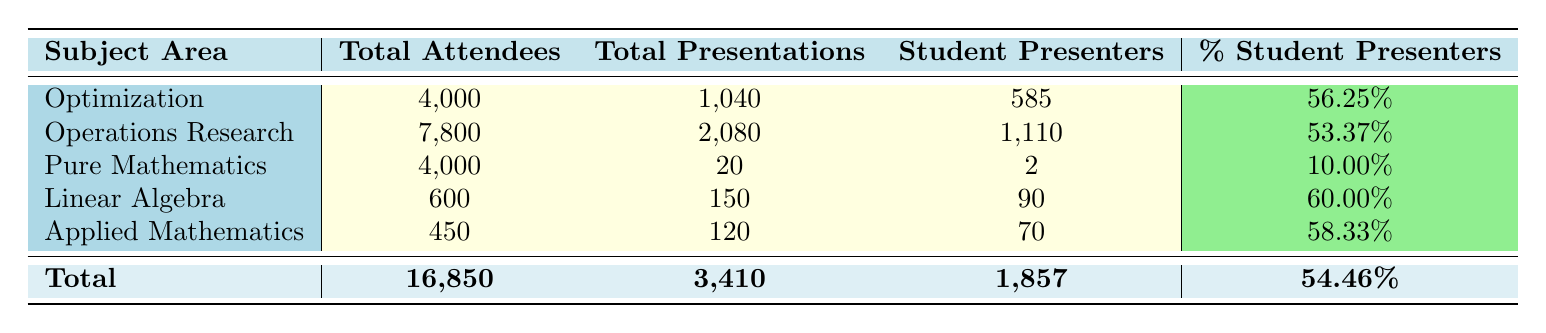What is the total number of attendees for the subject area "Optimization"? The total number of attendees for "Optimization" is directly provided in the table under that subject area. It is listed as 4,000.
Answer: 4,000 What is the percentage of student presenters in the subject area "Pure Mathematics"? The percentage of student presenters for "Pure Mathematics" is calculated by taking the number of student presenters (2) and dividing it by the total number of presentations (20), then multiplying by 100. So, (2/20)*100 = 10.00%.
Answer: 10.00% Which subject area has the highest number of total presentations? To find which subject area has the highest total presentations, we look at the "Total Presentations" column and identify the maximum value, which is 2,080 for "Operations Research".
Answer: Operations Research How many more student presenters does "Operations Research" have compared to "Linear Algebra"? The number of student presenters for "Operations Research" is 1,110 and for "Linear Algebra," it is 90. We find the difference by subtracting: 1,110 - 90 = 1,020.
Answer: 1,020 Is the total number of presentations across all subject areas greater than 3,000? We sum the total presentations for all subject areas: 1,040 + 2,080 + 20 + 150 + 120 = 3,410, which is indeed greater than 3,000. Thus, the statement is true.
Answer: Yes What is the average percentage of student presenters across all subject areas? To calculate the average percentage of student presenters, we add the percentages: 56.25%, 53.37%, 10.00%, 60.00%, and 58.33% which gives 237.95%. Then, we divide by the number of subject areas, which is 5: 237.95/5 = 47.59%.
Answer: 47.59% Which subject area has the least total attendees? Looking at the "Total Attendees" column, the subject area with the least total attendees is "Applied Mathematics" with 450 attendees.
Answer: Applied Mathematics What is the total combination of attendees for "Optimization" and "Applied Mathematics"? The total attendees for "Optimization" is 4,000 and for "Applied Mathematics" is 450. We add both values: 4,000 + 450 = 4,450.
Answer: 4,450 How many student presenters participated in the "International Congress of Mathematicians"? The number of student presenters for the "International Congress of Mathematicians" is explicitly stated as 2 in the table under that subject area.
Answer: 2 